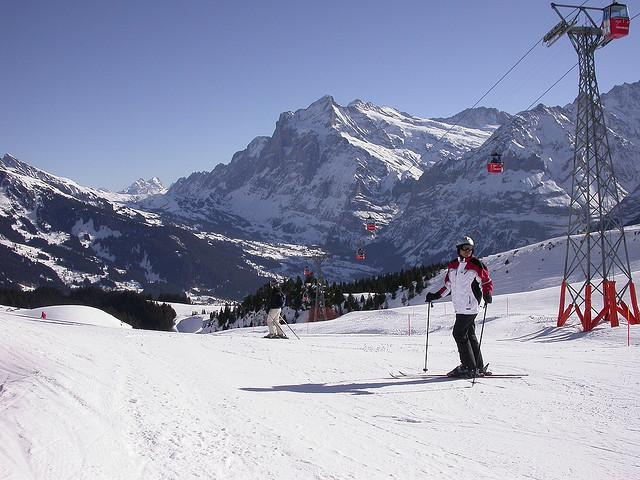Why are the bases of the towers brightly colored? be seen 